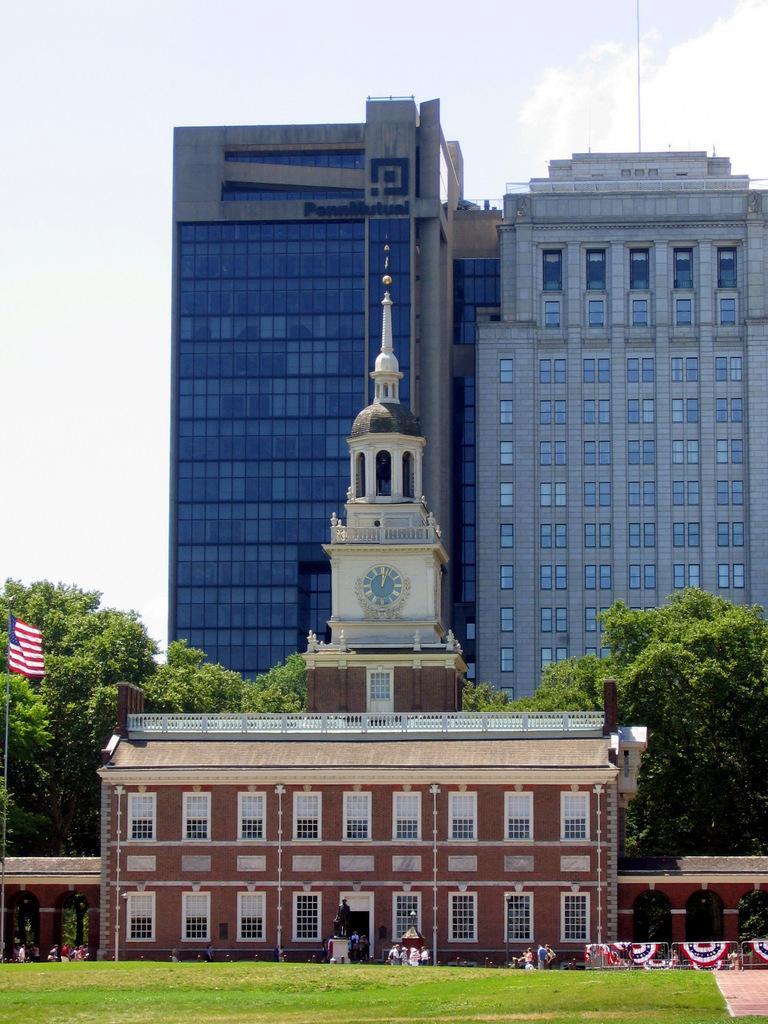Could you give a brief overview of what you see in this image? In this image there is a grassland, in the background there is a flag pole, buildings, trees and the sky. 